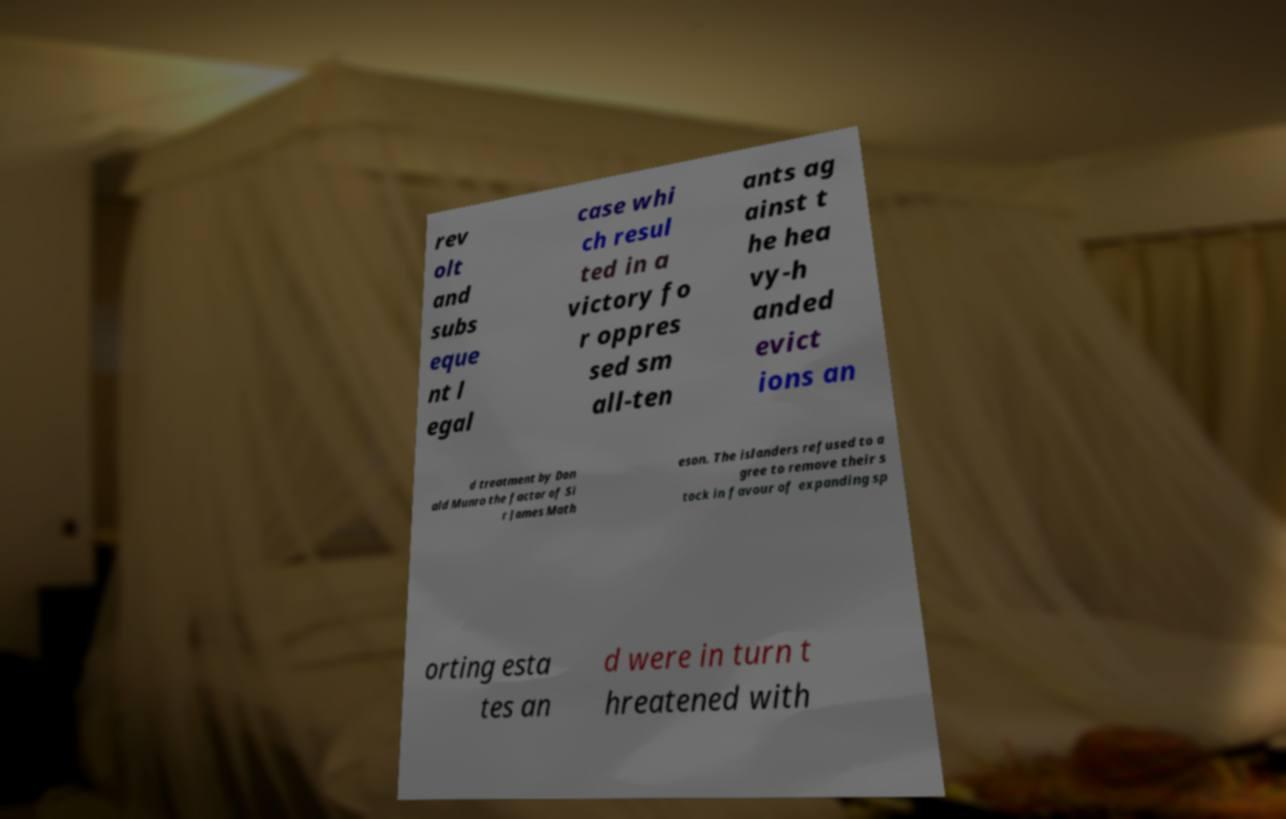Could you extract and type out the text from this image? rev olt and subs eque nt l egal case whi ch resul ted in a victory fo r oppres sed sm all-ten ants ag ainst t he hea vy-h anded evict ions an d treatment by Don ald Munro the factor of Si r James Math eson. The islanders refused to a gree to remove their s tock in favour of expanding sp orting esta tes an d were in turn t hreatened with 